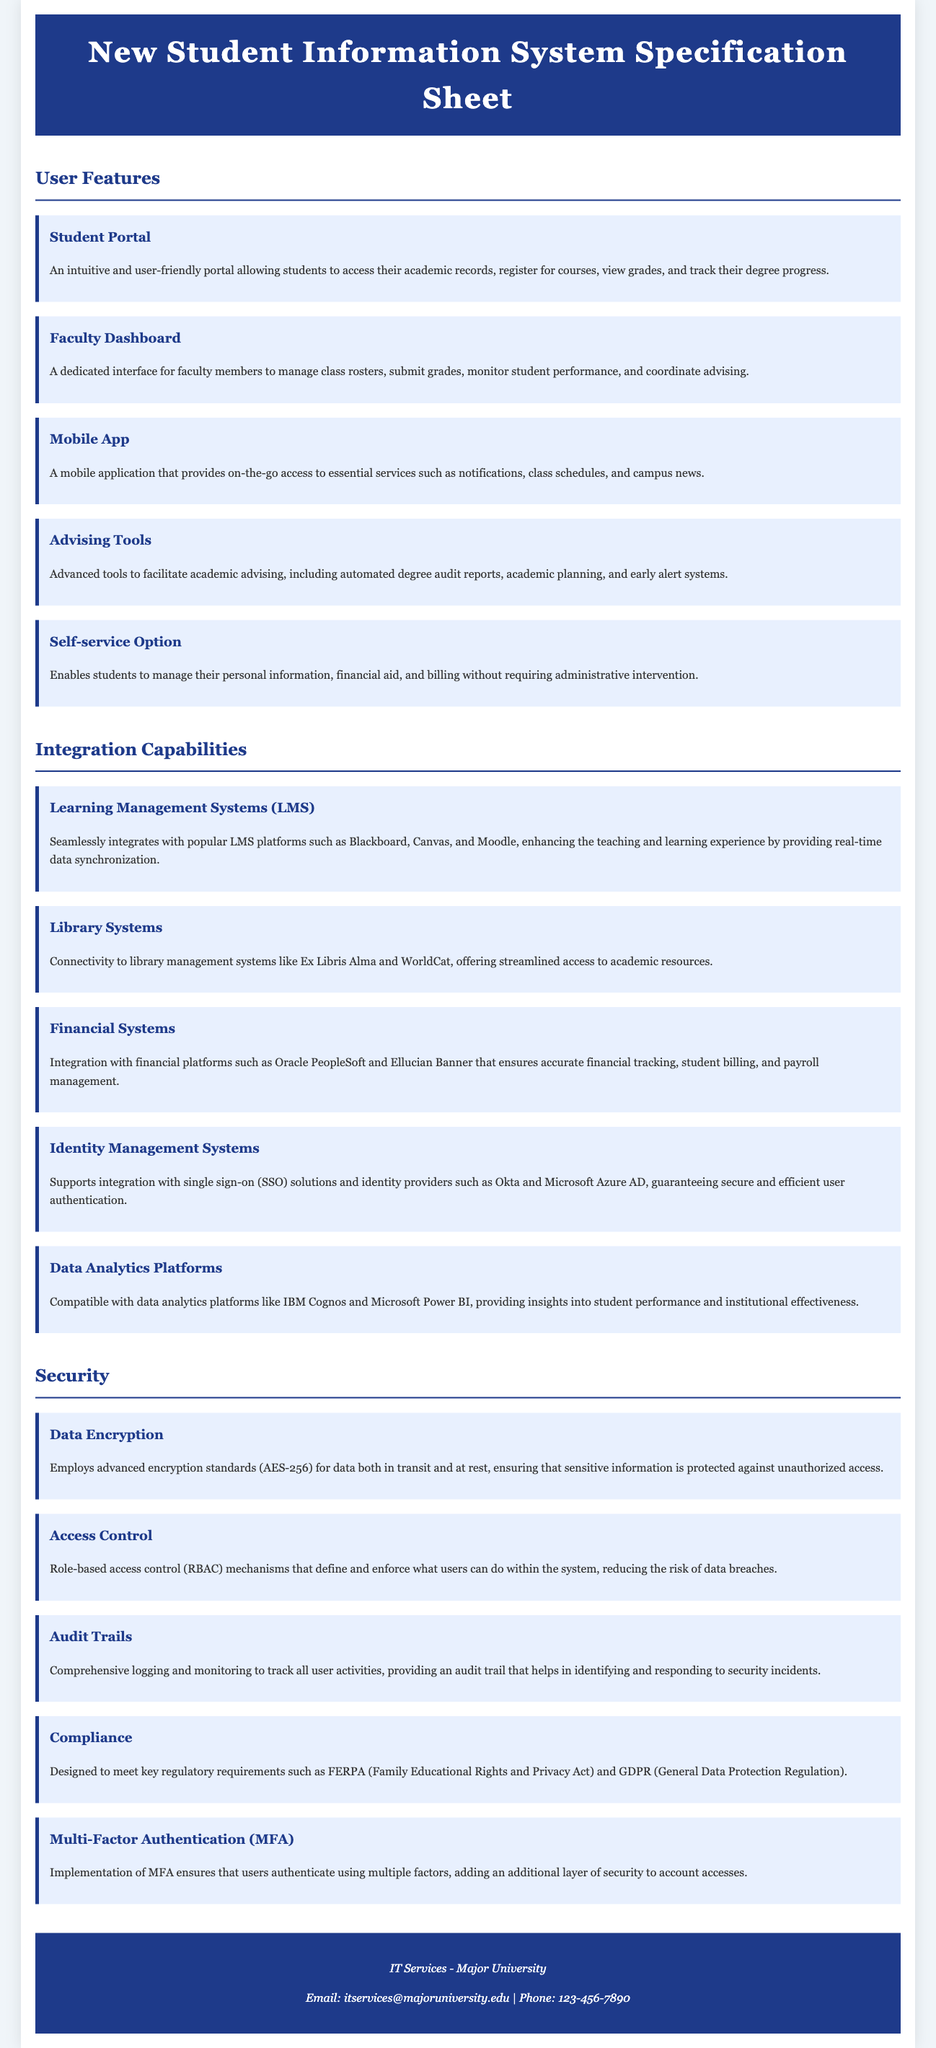What is a key feature of the Student Portal? The Student Portal allows students to access their academic records, register for courses, view grades, and track their degree progress.
Answer: Access academic records What mobile application functionality is mentioned? The mobile application provides on-the-go access to essential services such as notifications, class schedules, and campus news.
Answer: Notifications, class schedules, campus news How many integration capabilities are listed? The document outlines five integration capabilities related to the system.
Answer: Five What type of data encryption is used? The system employs advanced encryption standards, specifically AES-256.
Answer: AES-256 What is a benefit of the Role-based access control mechanism? Role-based access control reduces the risk of data breaches by defining and enforcing user actions within the system.
Answer: Reduces risk of data breaches Which regulatory requirements does the system comply with? The system is designed to meet regulatory requirements such as FERPA and GDPR.
Answer: FERPA, GDPR What does the Advising Tools feature include? Advising Tools include automated degree audit reports, academic planning, and early alert systems.
Answer: Automated degree audit reports Which platforms does the system integrate with for data analytics? It is compatible with data analytics platforms like IBM Cognos and Microsoft Power BI.
Answer: IBM Cognos and Microsoft Power BI What provides a layer of security during user authentication? The implementation of Multi-Factor Authentication ensures additional security for account accesses.
Answer: Multi-Factor Authentication 